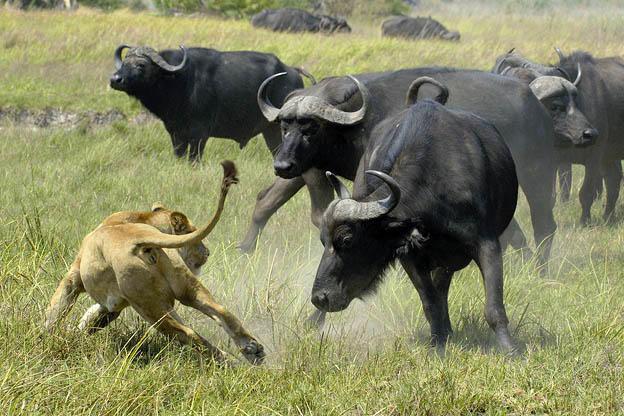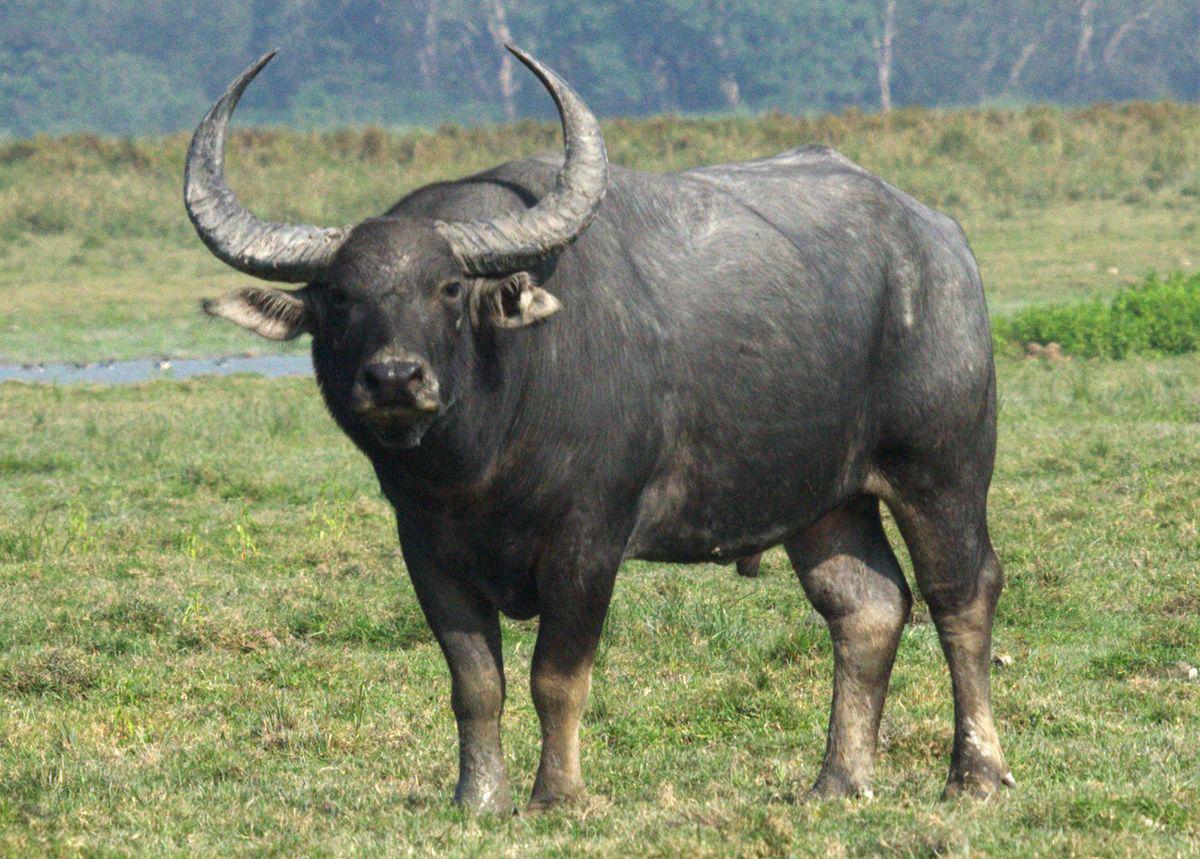The first image is the image on the left, the second image is the image on the right. Assess this claim about the two images: "The left image contains more water buffalos than the right image.". Correct or not? Answer yes or no. Yes. The first image is the image on the left, the second image is the image on the right. Given the left and right images, does the statement "There are no more than 3 water buffalo in the pair of images" hold true? Answer yes or no. No. The first image is the image on the left, the second image is the image on the right. Assess this claim about the two images: "At least 3 cows are standing in a grassy field.". Correct or not? Answer yes or no. Yes. The first image is the image on the left, the second image is the image on the right. For the images shown, is this caption "One animal stands in the grass in the image on the left." true? Answer yes or no. No. 